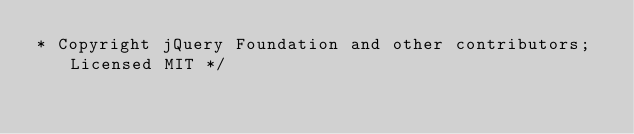<code> <loc_0><loc_0><loc_500><loc_500><_CSS_>* Copyright jQuery Foundation and other contributors; Licensed MIT */
</code> 